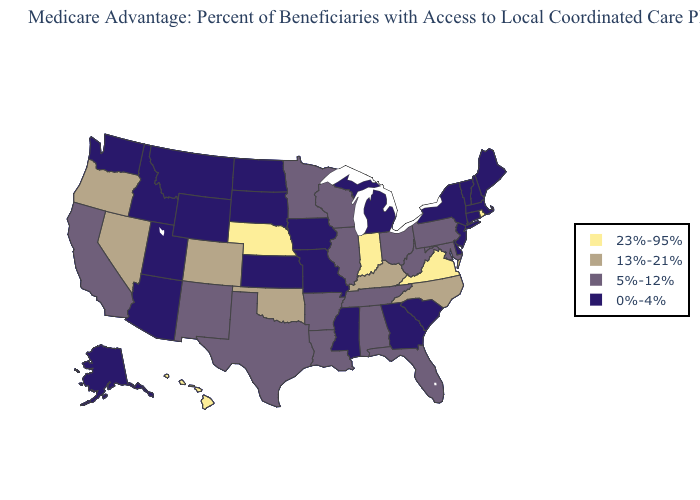What is the value of Kentucky?
Concise answer only. 13%-21%. Name the states that have a value in the range 13%-21%?
Answer briefly. Colorado, Kentucky, North Carolina, Nevada, Oklahoma, Oregon. What is the value of Wyoming?
Keep it brief. 0%-4%. Does North Carolina have the lowest value in the USA?
Answer briefly. No. Name the states that have a value in the range 0%-4%?
Quick response, please. Alaska, Arizona, Connecticut, Delaware, Georgia, Iowa, Idaho, Kansas, Massachusetts, Maine, Michigan, Missouri, Mississippi, Montana, North Dakota, New Hampshire, New Jersey, New York, South Carolina, South Dakota, Utah, Vermont, Washington, Wyoming. Name the states that have a value in the range 5%-12%?
Answer briefly. Alabama, Arkansas, California, Florida, Illinois, Louisiana, Maryland, Minnesota, New Mexico, Ohio, Pennsylvania, Tennessee, Texas, Wisconsin, West Virginia. What is the value of Utah?
Be succinct. 0%-4%. What is the value of Mississippi?
Write a very short answer. 0%-4%. Does New Mexico have a lower value than North Dakota?
Short answer required. No. Name the states that have a value in the range 23%-95%?
Give a very brief answer. Hawaii, Indiana, Nebraska, Rhode Island, Virginia. Which states have the highest value in the USA?
Concise answer only. Hawaii, Indiana, Nebraska, Rhode Island, Virginia. What is the lowest value in the MidWest?
Quick response, please. 0%-4%. Does Maryland have a lower value than Kentucky?
Quick response, please. Yes. Does Nevada have the same value as Wisconsin?
Give a very brief answer. No. Does Illinois have the lowest value in the MidWest?
Write a very short answer. No. 